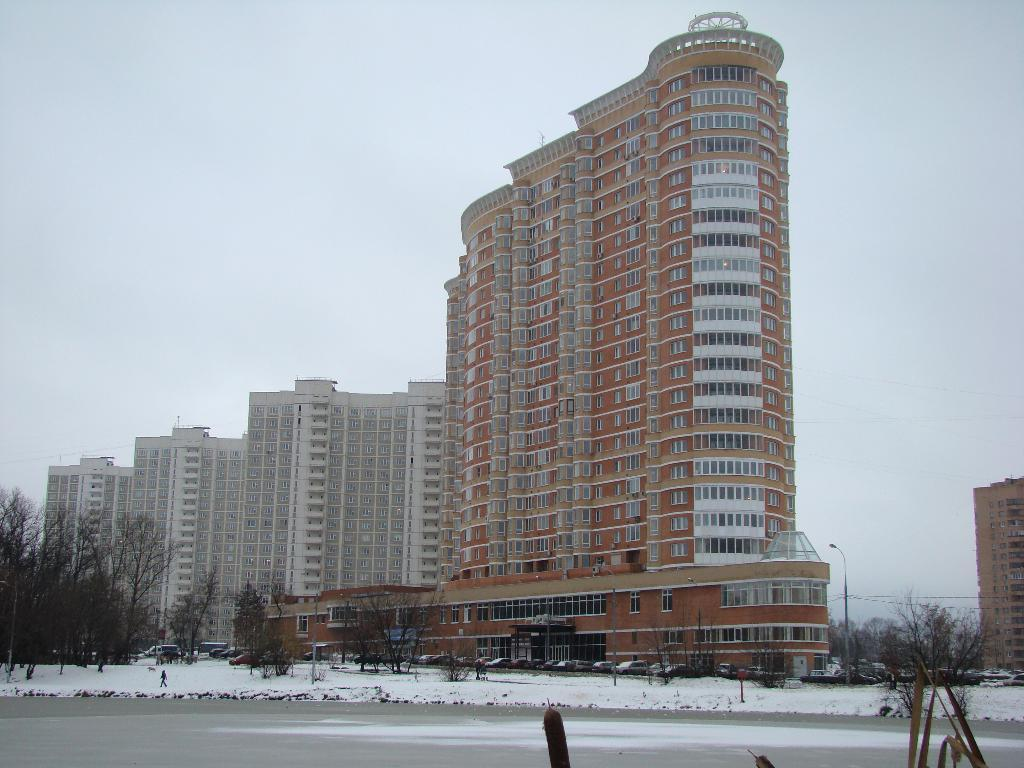What is the main feature of the image? There is a road in the image. What is the weather like in the image? There is snow in the image. What type of vegetation is present in the image? There are trees in the image. Can you describe the person in the image? There is a person in the image. What are the poles used for in the image? The poles are likely used to support the wires in the image. What type of transportation can be seen in the image? There are vehicles in the image. What type of structures are present in the image? There are buildings in the image. How many cats are playing with a wrench in the image? There are no cats or wrenches present in the image. 